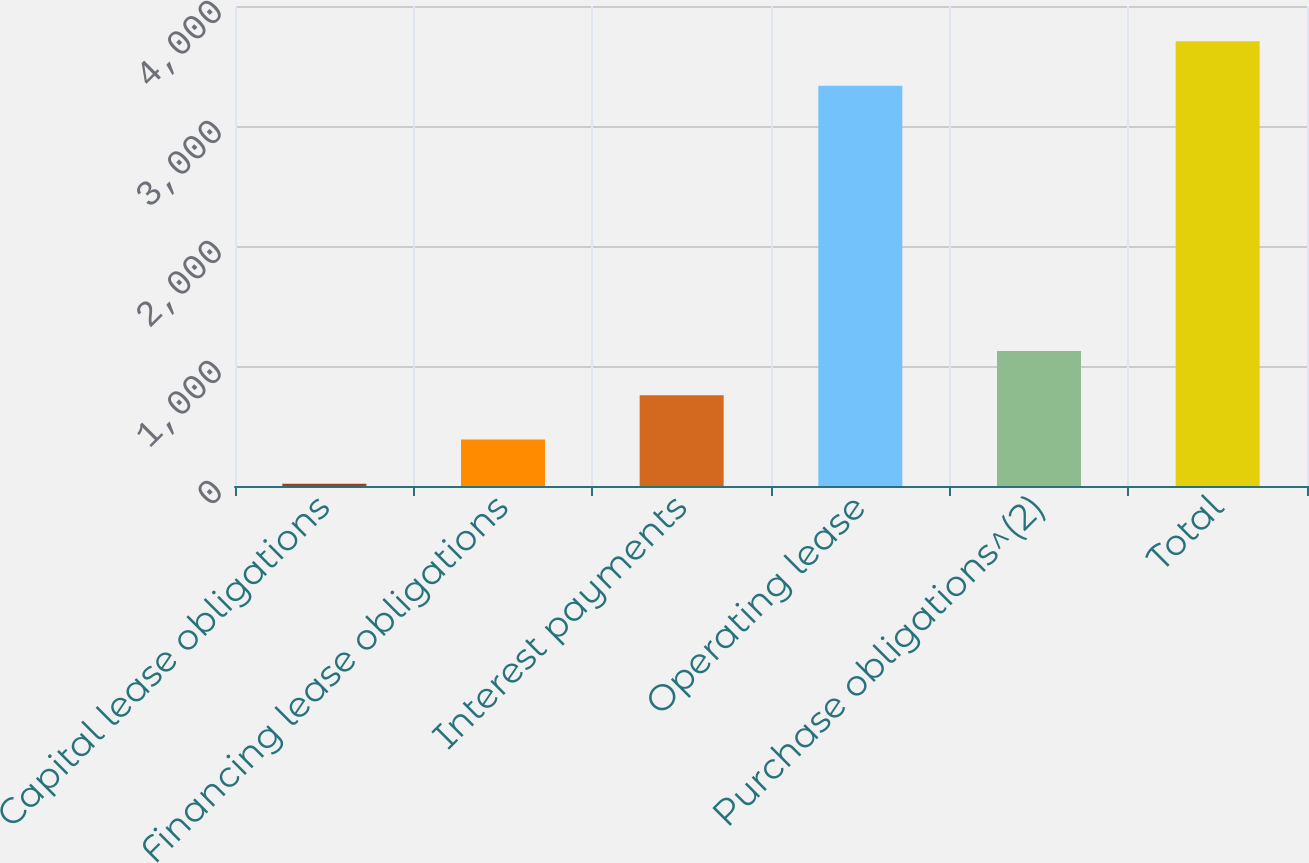<chart> <loc_0><loc_0><loc_500><loc_500><bar_chart><fcel>Capital lease obligations<fcel>Financing lease obligations<fcel>Interest payments<fcel>Operating lease<fcel>Purchase obligations^(2)<fcel>Total<nl><fcel>18<fcel>386.8<fcel>755.6<fcel>3335<fcel>1124.4<fcel>3706<nl></chart> 